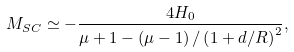Convert formula to latex. <formula><loc_0><loc_0><loc_500><loc_500>M _ { S C } \simeq - \frac { 4 H _ { 0 } } { \mu + 1 - \left ( \mu - 1 \right ) / \left ( 1 + d / R \right ) ^ { 2 } } ,</formula> 